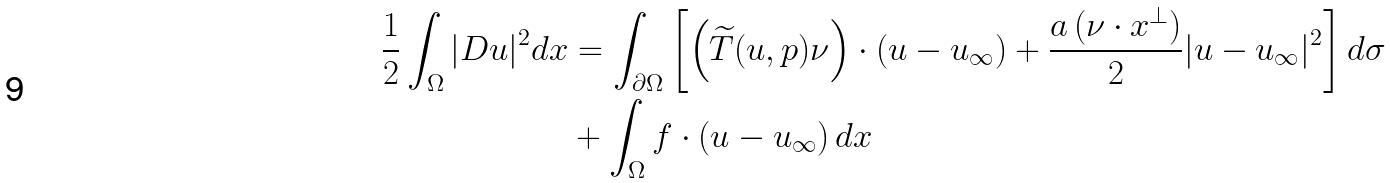Convert formula to latex. <formula><loc_0><loc_0><loc_500><loc_500>\frac { 1 } { 2 } \int _ { \Omega } | D u | ^ { 2 } d x & = \int _ { \partial \Omega } \left [ \left ( \widetilde { T } ( u , p ) \nu \right ) \cdot ( u - u _ { \infty } ) + \frac { a \, ( \nu \cdot x ^ { \perp } ) } { 2 } | u - u _ { \infty } | ^ { 2 } \right ] d \sigma \\ & + \int _ { \Omega } f \cdot ( u - u _ { \infty } ) \, d x</formula> 